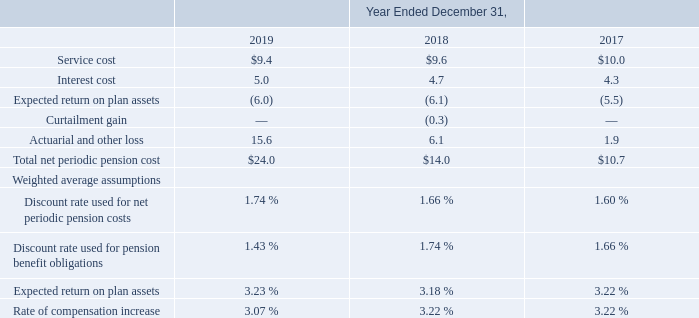Defined Benefit Pension Plans
The Company maintains defined benefit pension plans for employees of certain of its foreign subsidiaries. Such plans conform to local practice in terms of providing minimum benefits mandated by law, collective agreements or customary practice. The Company recognizes the aggregate amount of all overfunded plans as assets and the aggregate amount of all underfunded plans as liabilities in its financial statements.
The Company's expected long-term rate of return on plan assets is updated at least annually, taking into consideration its asset allocation, historical returns on similar types of assets and the current economic environment. For estimation purposes, the Company assumes its long-term asset mix will generally be consistent with the current mix. The Company determines its discount rates using highly rated corporate bond yields and government bond yields.
Benefits under all of the Company's plans are valued utilizing the projected unit credit cost method. The Company's policy is to fund its defined benefit plans in accordance with local requirements and regulations. The funding is primarily driven by the Company's current assessment of the economic environment and projected benefit payments of its foreign subsidiaries. The Company's measurement date for determining its defined benefit obligations for all plans is December 31 of each year.
The Company recognizes actuarial gains and losses in the period the Company's annual pension plan actuarial valuations are prepared, which generally occurs during the fourth quarter of each year, or during any interim period where a revaluation is deemed necessary.
The following is a summary of the status of the Company's foreign defined benefit pension plans and the net periodic pension cost (dollars in millions):
The long term rate of return on plan assets was determined using the weighted-average method, which incorporates factors that include the historical inflation rates, interest rate yield curve and current market conditions.
What is the service cost in 2019?
Answer scale should be: million. $9.4. What is the service cost in 2018?
Answer scale should be: million. $9.6. What is the interest cost in 2018?
Answer scale should be: million. 4.7. What is the change in Service cost from December 31, 2018 to 2019?
Answer scale should be: million. 9.4-9.6
Answer: -0.2. What is the change in Interest cost from year ended December 31, 2018 to 2019?
Answer scale should be: million. 5.0-4.7
Answer: 0.3. What is the average Service cost for December 31, 2018 and 2019?
Answer scale should be: million. (9.4+9.6) / 2
Answer: 9.5. 